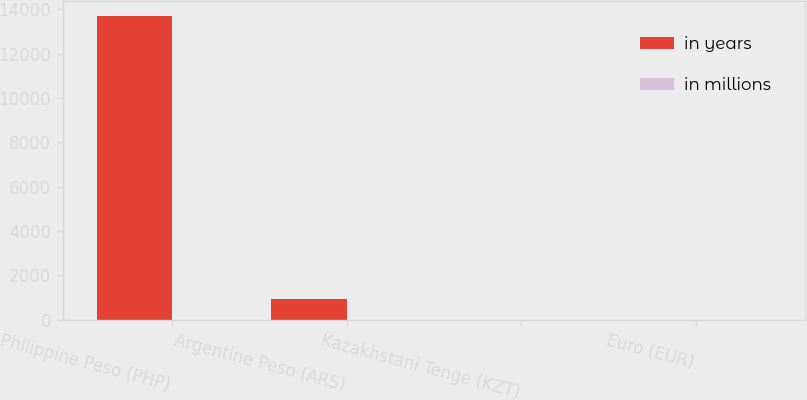Convert chart. <chart><loc_0><loc_0><loc_500><loc_500><stacked_bar_chart><ecel><fcel>Philippine Peso (PHP)<fcel>Argentine Peso (ARS)<fcel>Kazakhstani Tenge (KZT)<fcel>Euro (EUR)<nl><fcel>in years<fcel>13692<fcel>938<fcel>9<fcel>3<nl><fcel>in millions<fcel>2<fcel>11<fcel>8<fcel>9<nl></chart> 